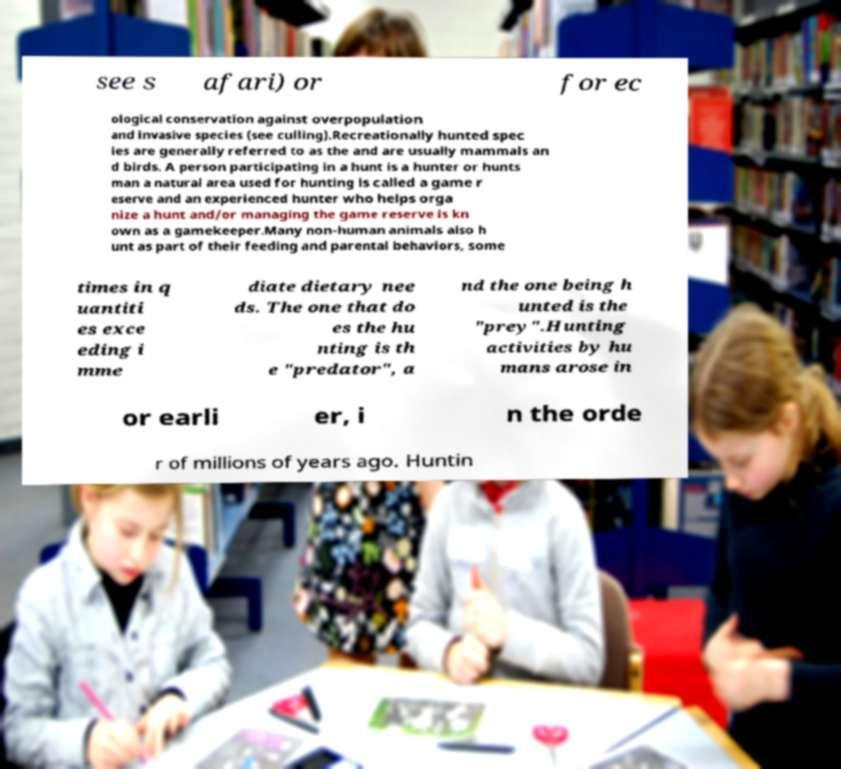I need the written content from this picture converted into text. Can you do that? see s afari) or for ec ological conservation against overpopulation and invasive species (see culling).Recreationally hunted spec ies are generally referred to as the and are usually mammals an d birds. A person participating in a hunt is a hunter or hunts man a natural area used for hunting is called a game r eserve and an experienced hunter who helps orga nize a hunt and/or managing the game reserve is kn own as a gamekeeper.Many non-human animals also h unt as part of their feeding and parental behaviors, some times in q uantiti es exce eding i mme diate dietary nee ds. The one that do es the hu nting is th e "predator", a nd the one being h unted is the "prey".Hunting activities by hu mans arose in or earli er, i n the orde r of millions of years ago. Huntin 